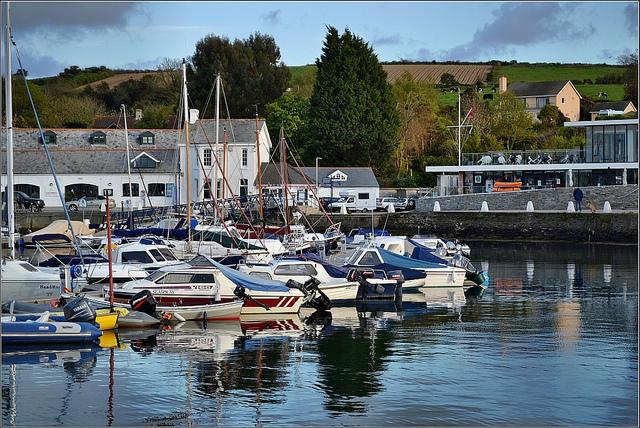Why is the hill above the sea brown with furrows? farming 